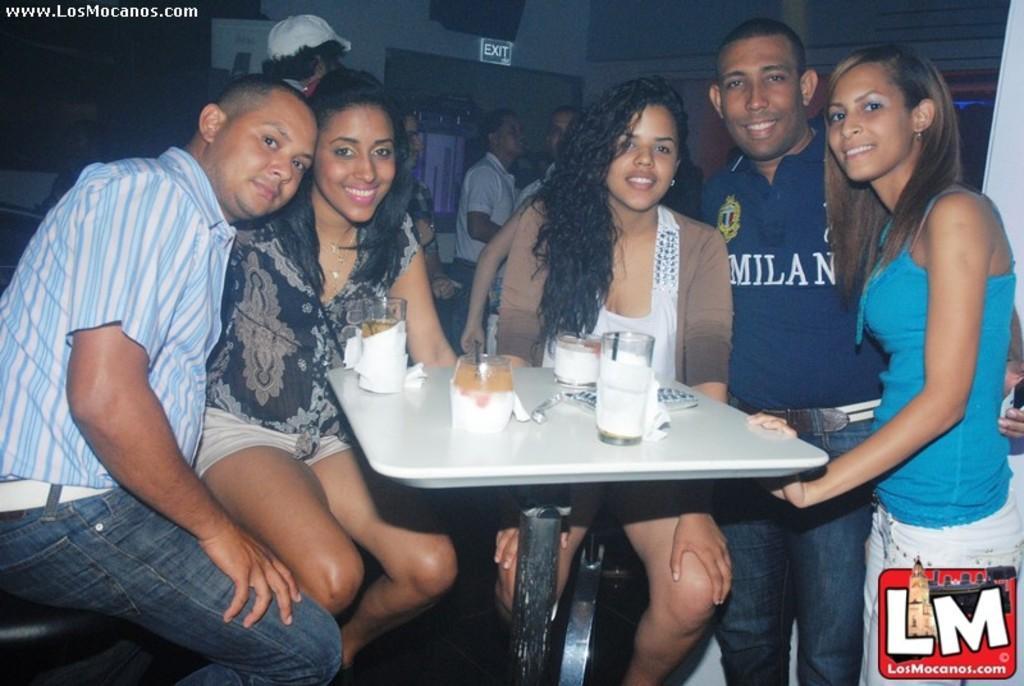Could you give a brief overview of what you see in this image? In this picture we can see three people sitting on the chairs and two people standing in front of the table on which there are some classes and some things and behind are some people standing. 